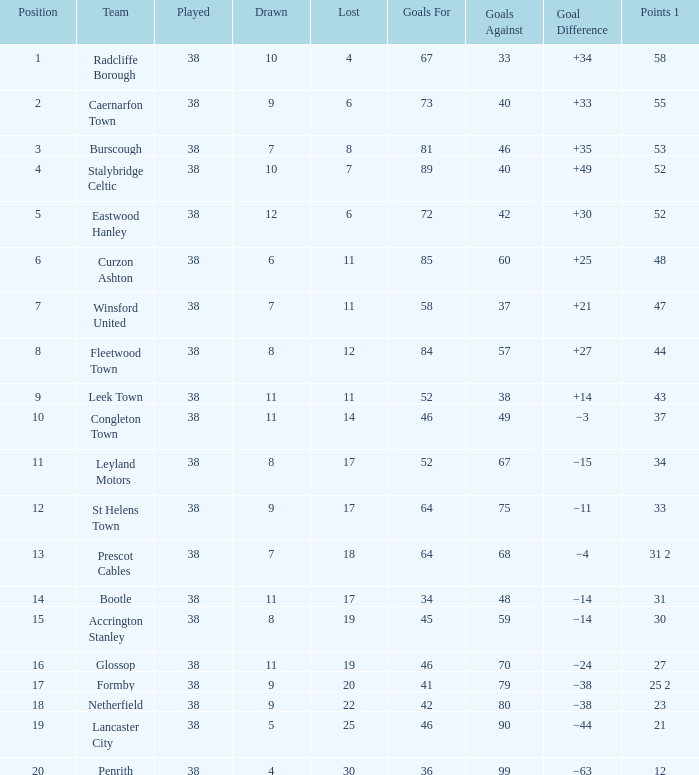WHAT GOALS AGAINST HAD A GOAL FOR OF 46, AND PLAYED LESS THAN 38? None. 